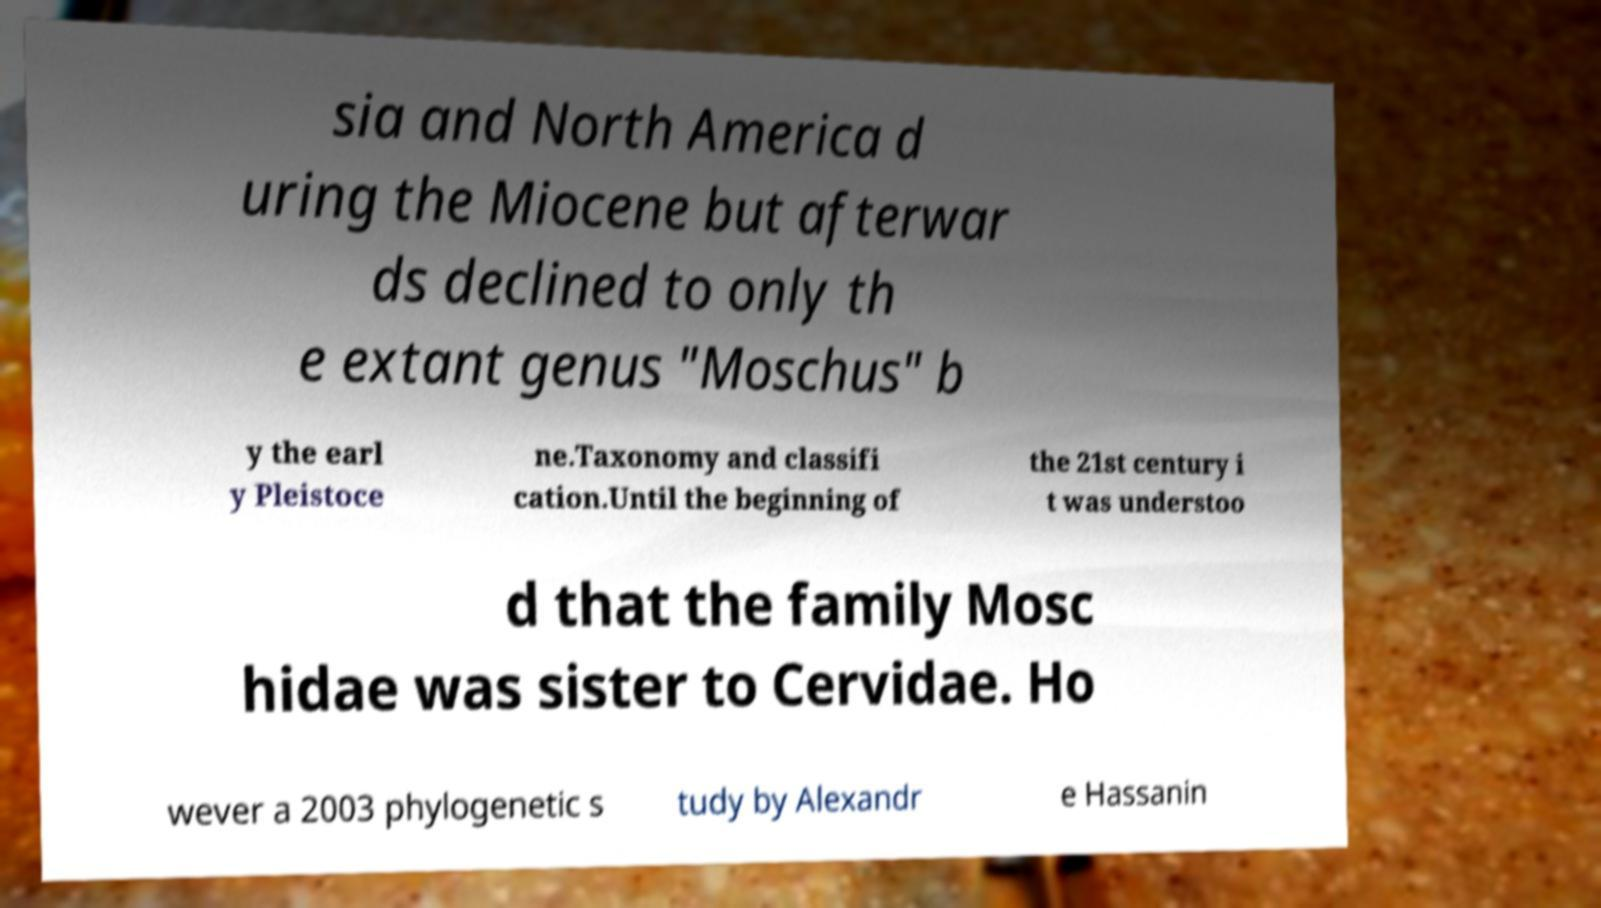What messages or text are displayed in this image? I need them in a readable, typed format. sia and North America d uring the Miocene but afterwar ds declined to only th e extant genus "Moschus" b y the earl y Pleistoce ne.Taxonomy and classifi cation.Until the beginning of the 21st century i t was understoo d that the family Mosc hidae was sister to Cervidae. Ho wever a 2003 phylogenetic s tudy by Alexandr e Hassanin 